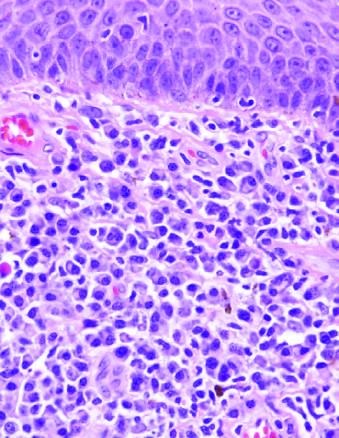what include a diffuse plasma cell infiltrate beneath squamous epithelium of skin?
Answer the question using a single word or phrase. Histologic features of the chancre 